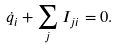<formula> <loc_0><loc_0><loc_500><loc_500>\dot { q } _ { i } + \sum _ { j } I _ { j i } = 0 .</formula> 